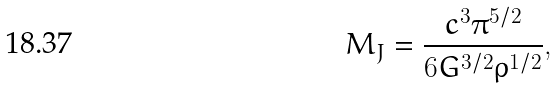Convert formula to latex. <formula><loc_0><loc_0><loc_500><loc_500>M _ { J } = \frac { c ^ { 3 } \pi ^ { 5 / 2 } } { 6 G ^ { 3 / 2 } \rho ^ { 1 / 2 } } ,</formula> 